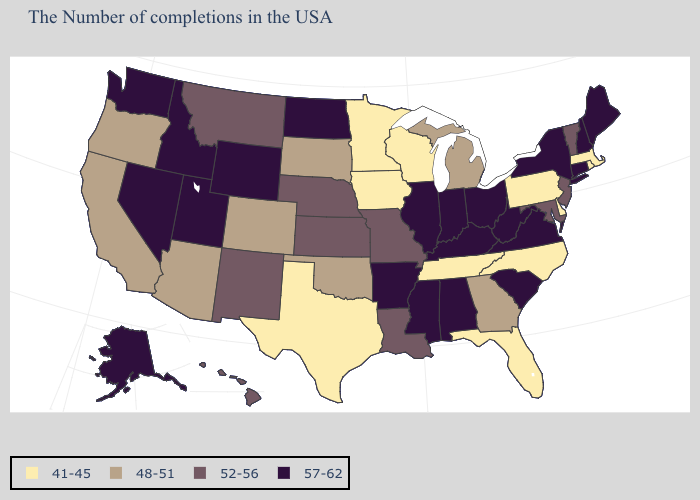Among the states that border Tennessee , does North Carolina have the highest value?
Concise answer only. No. Which states have the lowest value in the South?
Give a very brief answer. Delaware, North Carolina, Florida, Tennessee, Texas. Is the legend a continuous bar?
Concise answer only. No. How many symbols are there in the legend?
Short answer required. 4. Which states have the highest value in the USA?
Be succinct. Maine, New Hampshire, Connecticut, New York, Virginia, South Carolina, West Virginia, Ohio, Kentucky, Indiana, Alabama, Illinois, Mississippi, Arkansas, North Dakota, Wyoming, Utah, Idaho, Nevada, Washington, Alaska. Name the states that have a value in the range 52-56?
Write a very short answer. Vermont, New Jersey, Maryland, Louisiana, Missouri, Kansas, Nebraska, New Mexico, Montana, Hawaii. What is the value of New Mexico?
Quick response, please. 52-56. Name the states that have a value in the range 41-45?
Keep it brief. Massachusetts, Rhode Island, Delaware, Pennsylvania, North Carolina, Florida, Tennessee, Wisconsin, Minnesota, Iowa, Texas. Does the first symbol in the legend represent the smallest category?
Be succinct. Yes. Name the states that have a value in the range 52-56?
Quick response, please. Vermont, New Jersey, Maryland, Louisiana, Missouri, Kansas, Nebraska, New Mexico, Montana, Hawaii. What is the value of Kansas?
Concise answer only. 52-56. Among the states that border South Carolina , does North Carolina have the highest value?
Give a very brief answer. No. What is the value of Connecticut?
Answer briefly. 57-62. What is the highest value in the USA?
Quick response, please. 57-62. What is the highest value in the USA?
Answer briefly. 57-62. 